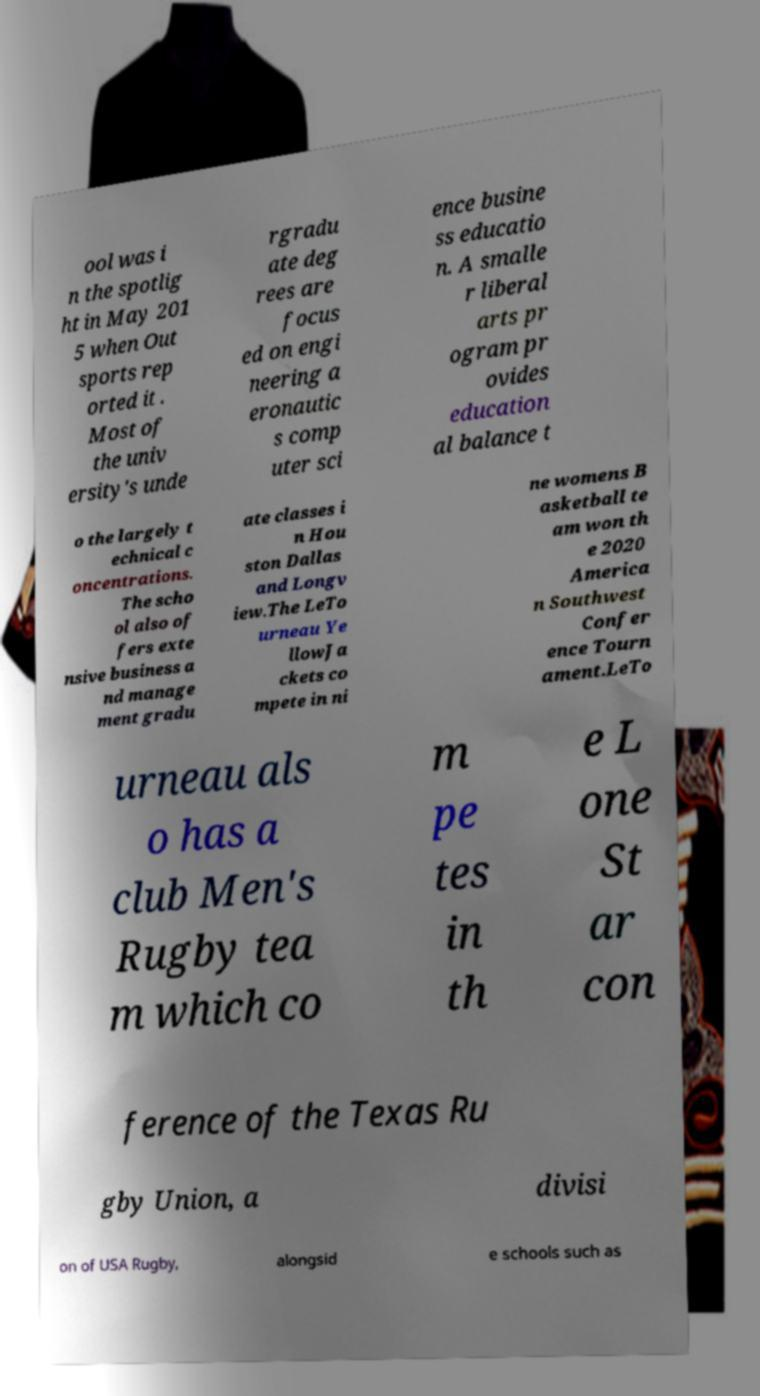What messages or text are displayed in this image? I need them in a readable, typed format. ool was i n the spotlig ht in May 201 5 when Out sports rep orted it . Most of the univ ersity's unde rgradu ate deg rees are focus ed on engi neering a eronautic s comp uter sci ence busine ss educatio n. A smalle r liberal arts pr ogram pr ovides education al balance t o the largely t echnical c oncentrations. The scho ol also of fers exte nsive business a nd manage ment gradu ate classes i n Hou ston Dallas and Longv iew.The LeTo urneau Ye llowJa ckets co mpete in ni ne womens B asketball te am won th e 2020 America n Southwest Confer ence Tourn ament.LeTo urneau als o has a club Men's Rugby tea m which co m pe tes in th e L one St ar con ference of the Texas Ru gby Union, a divisi on of USA Rugby, alongsid e schools such as 